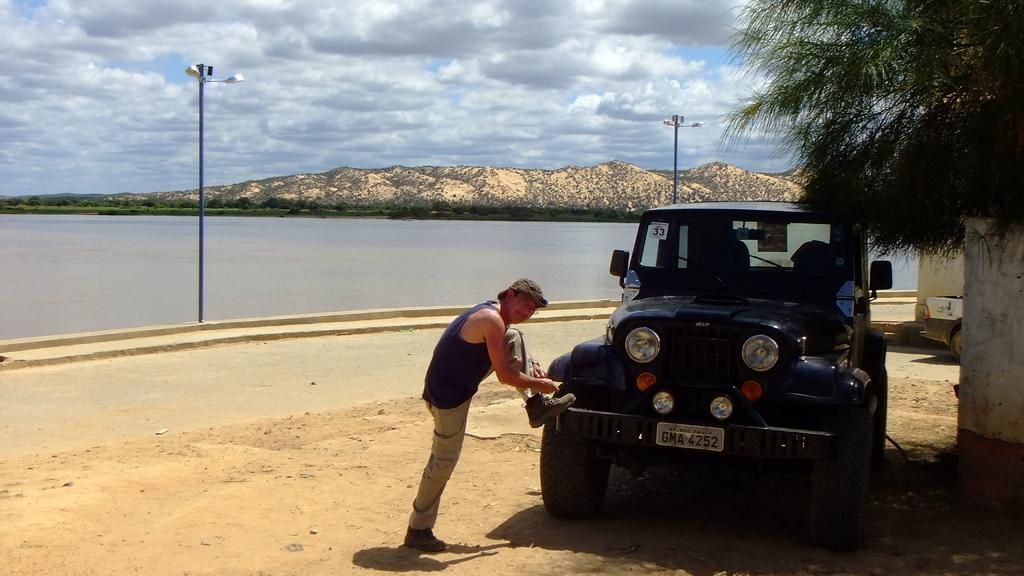How would you summarize this image in a sentence or two? In the middle of the image we can see a man, in front of him we can see a vehicle and a tree, in the background we can find few poles, water, hills, few more trees and clouds. 